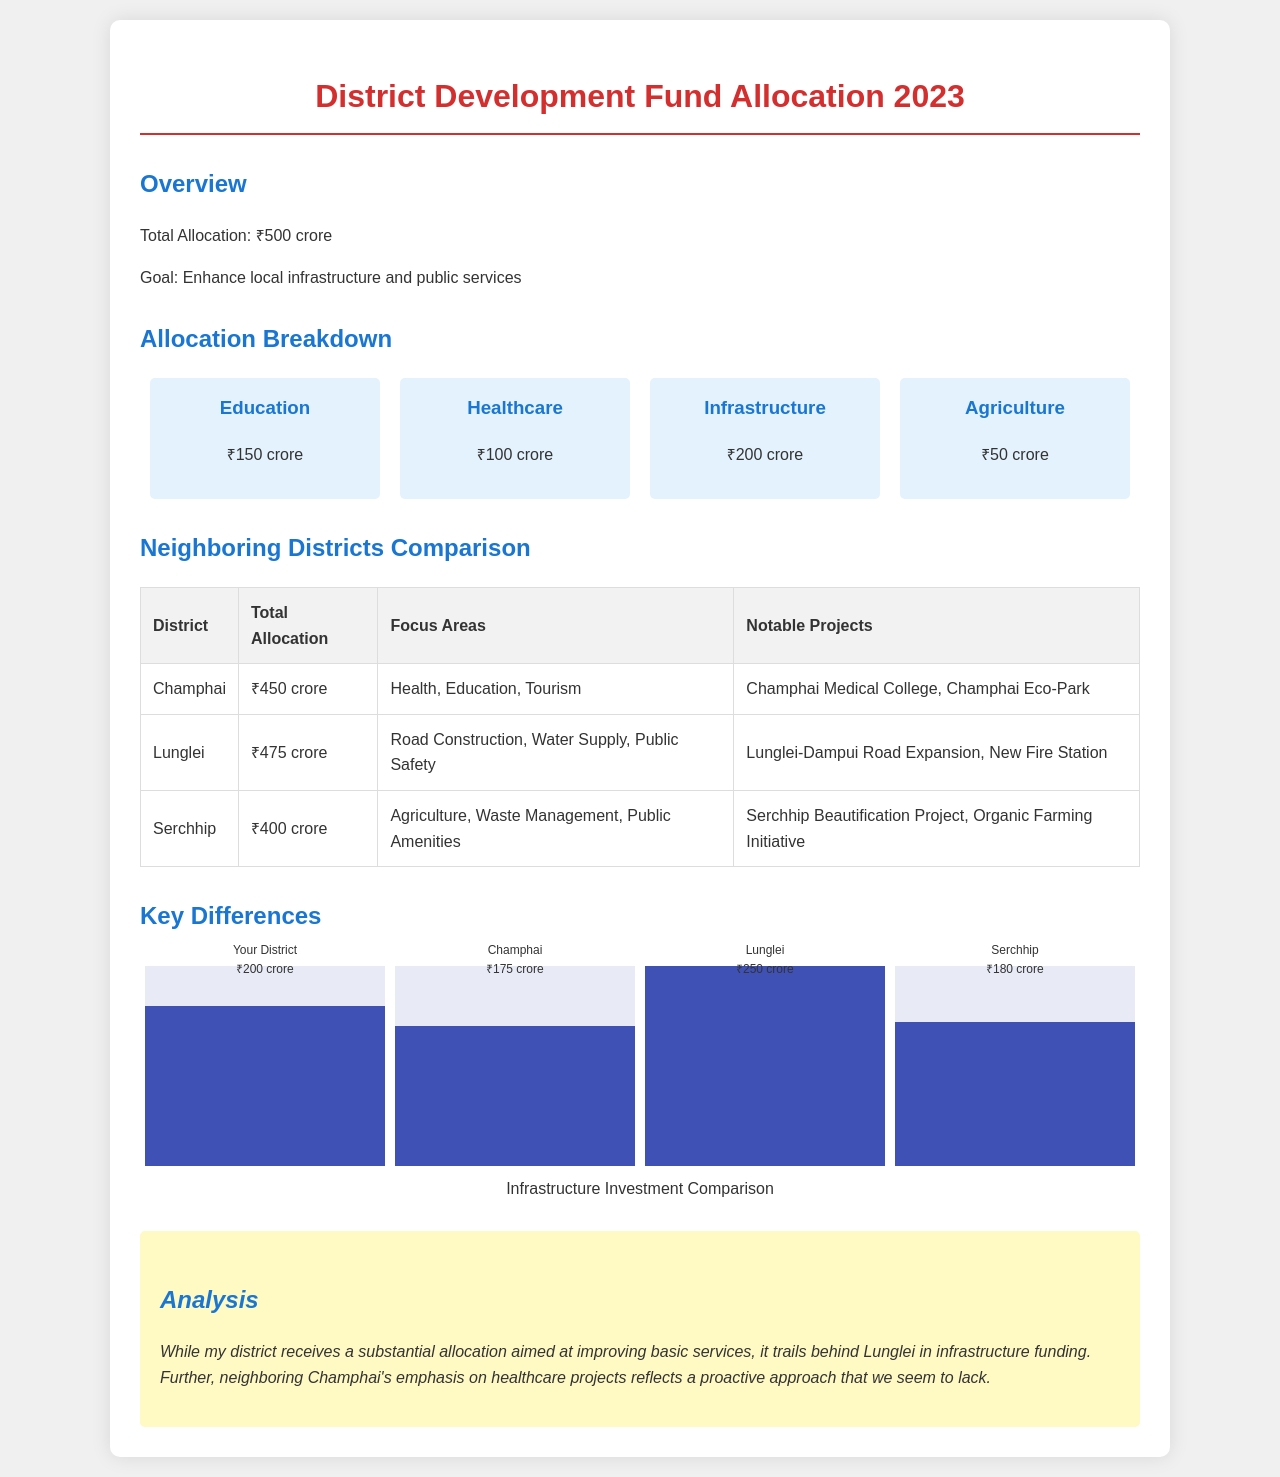What is the total allocation for the district? The total allocation is stated at the beginning of the document, which is ₹500 crore.
Answer: ₹500 crore How much is allocated for healthcare? The healthcare allocation is specified in the allocation breakdown section of the document, which lists ₹100 crore.
Answer: ₹100 crore Which district has the highest total allocation? By comparing the total allocations listed for neighboring districts, Lunglei has ₹475 crore, making it the highest.
Answer: Lunglei What notable project is mentioned for Champhai? The notable project listed under Champhai is the Champhai Medical College, detailed in the neighboring districts table.
Answer: Champhai Medical College What is the percentage of the allocation for infrastructure in your district? The infrastructure allocation is ₹200 crore out of ₹500 crore total, which is 40%.
Answer: ₹200 crore Which neighboring district focuses on tourism? In the neighboring districts comparison section, Champhai emphasizes tourism as one of its focus areas.
Answer: Champhai What is the main goal of the fund allocation? The main goal is explicitly stated to enhance local infrastructure and public services.
Answer: Enhance local infrastructure and public services How does your district's infrastructure allocation compare to Lunglei's? In the analysis section, it's mentioned that my district trails behind Lunglei in infrastructure funding.
Answer: Trails behind What is the focus area of the district with a total allocation of ₹400 crore? The focus areas for the district with ₹400 crore allocation, Serchhip, are stated as agriculture, waste management, and public amenities.
Answer: Agriculture, Waste Management, Public Amenities 